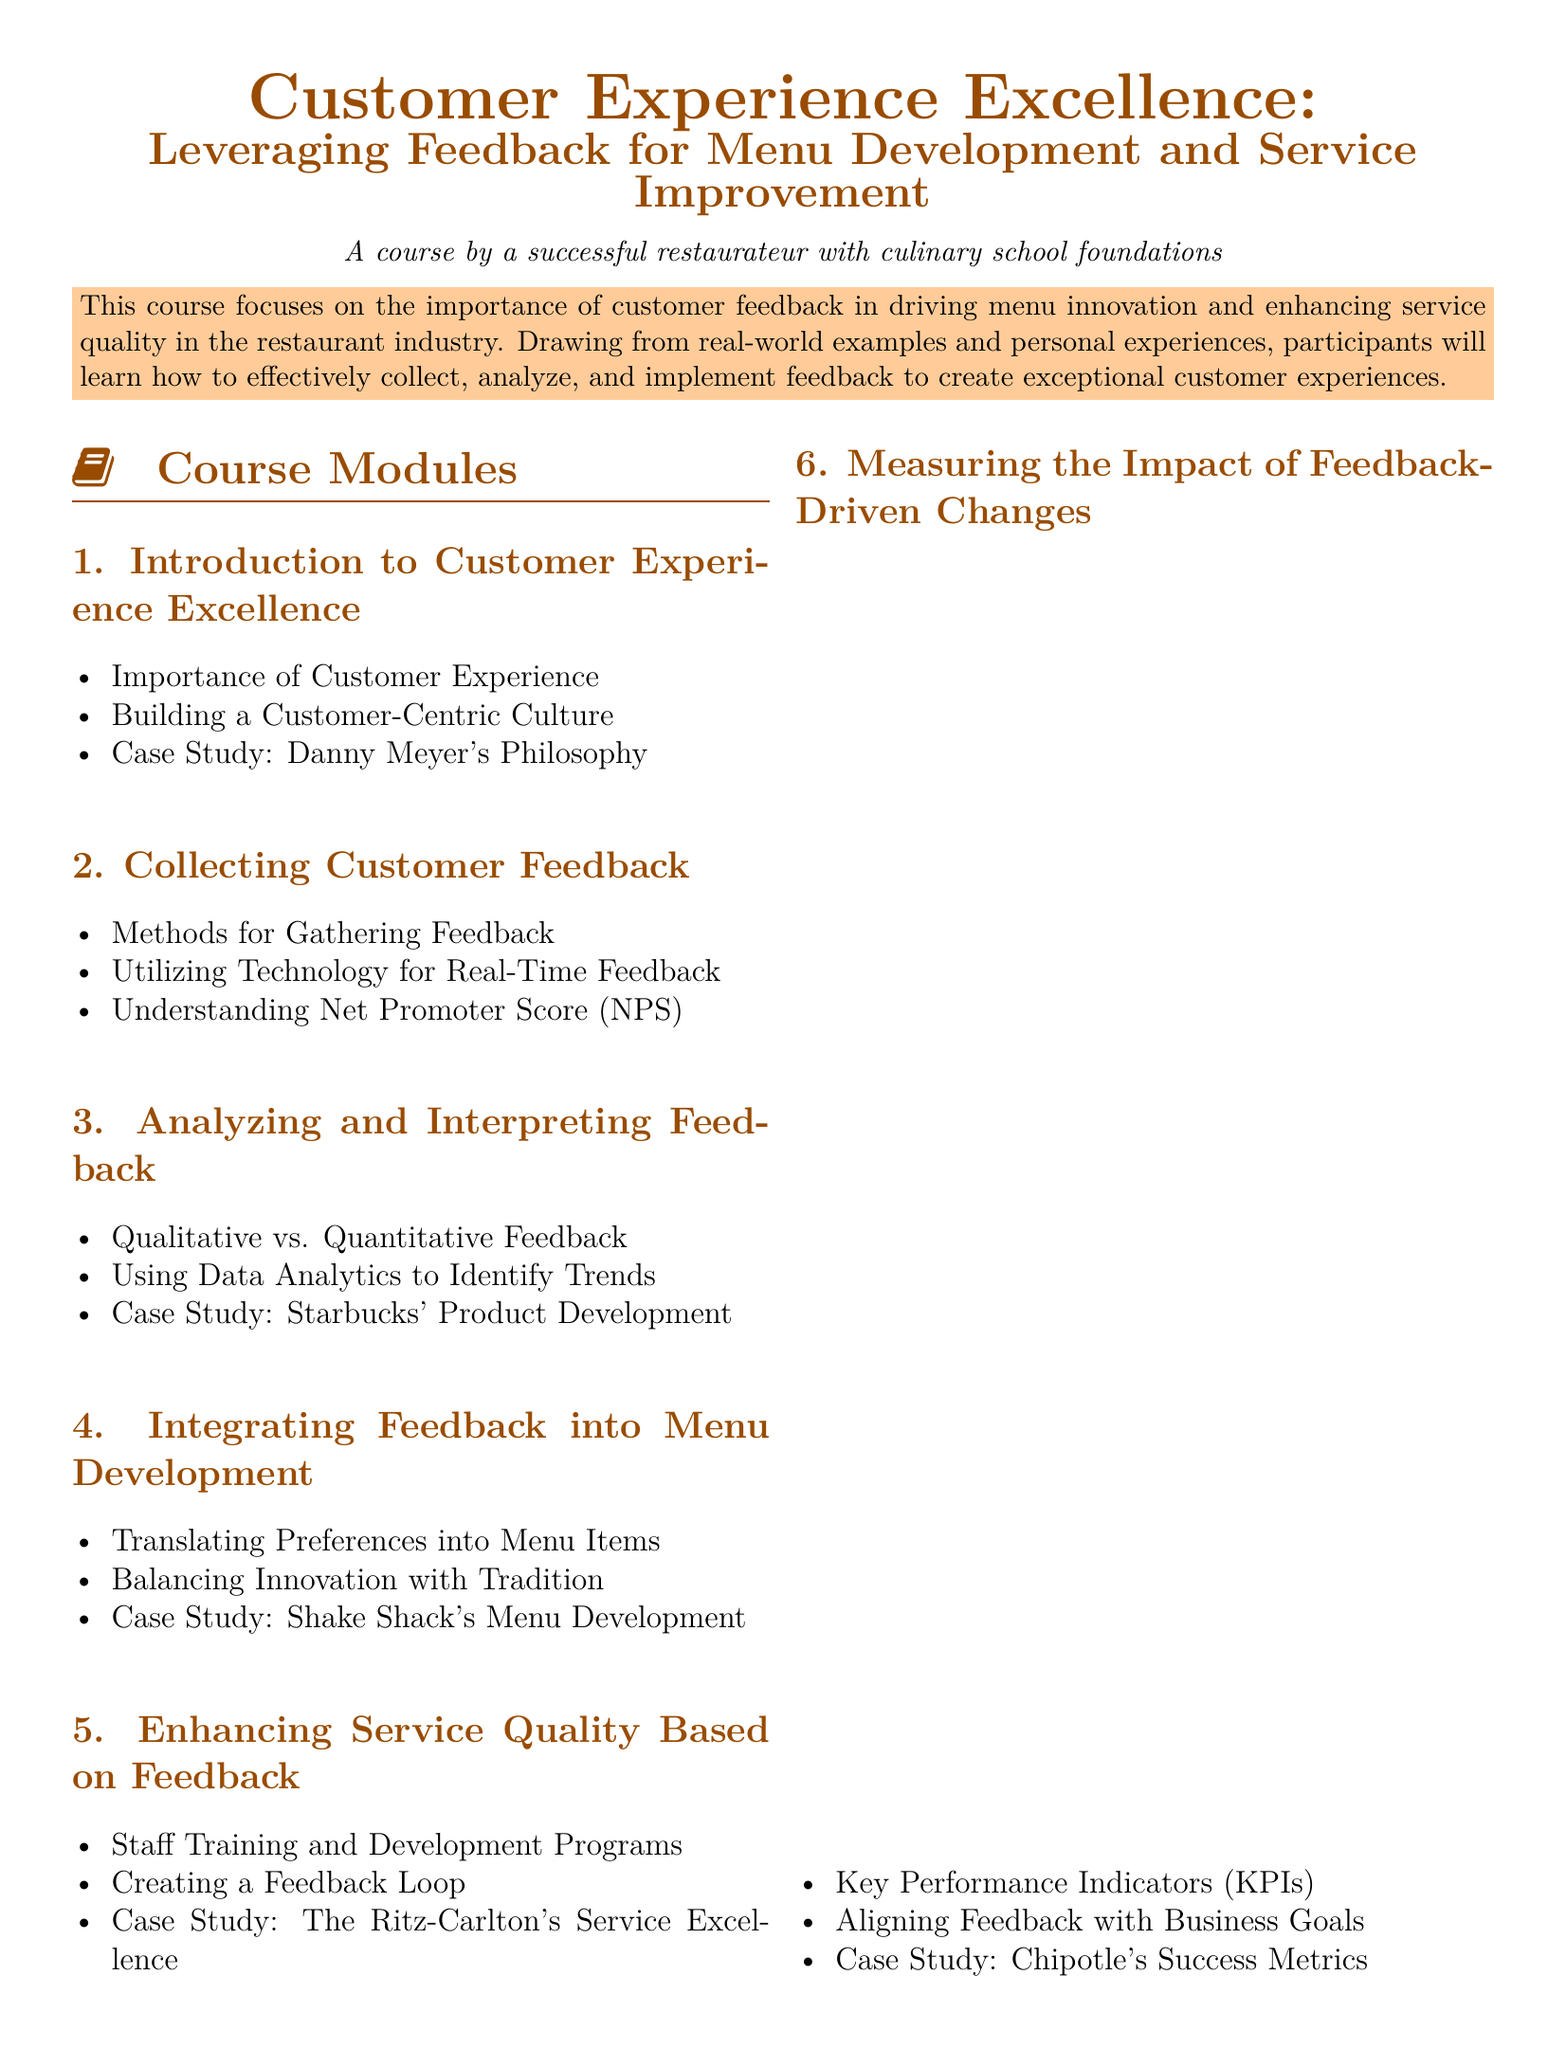What is the title of the course? The title of the course is the main heading at the top of the document.
Answer: Customer Experience Excellence: Leveraging Feedback for Menu Development and Service Improvement Who is the course designed by? The document states who designed the course in the introduction section.
Answer: A successful restaurateur with culinary school foundations What is the first module of the course? The first item in the course modules section lists the initial topic covered in the syllabus.
Answer: Introduction to Customer Experience Excellence Which case study is mentioned in the module about integrating feedback into menu development? The document lists specific case studies under each module, including this one.
Answer: Shake Shack's Menu Development What does NPS stand for? The acronym NPS is explained in the context of collecting customer feedback.
Answer: Net Promoter Score How many required readings are listed in the syllabus? The total number of items in the required readings section can be counted.
Answer: 12 Which company is referenced in the module on analyzing and interpreting feedback? The syllabus provides a specific example of a well-known company in this section.
Answer: Starbucks What is the focus of the course? This information is found in the initial description of the course within the document.
Answer: Importance of customer feedback in driving menu innovation and enhancing service quality 